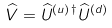Convert formula to latex. <formula><loc_0><loc_0><loc_500><loc_500>\widehat { V } = \widehat { U } ^ { ( u ) \, \dagger } \widehat { U } ^ { ( d ) }</formula> 